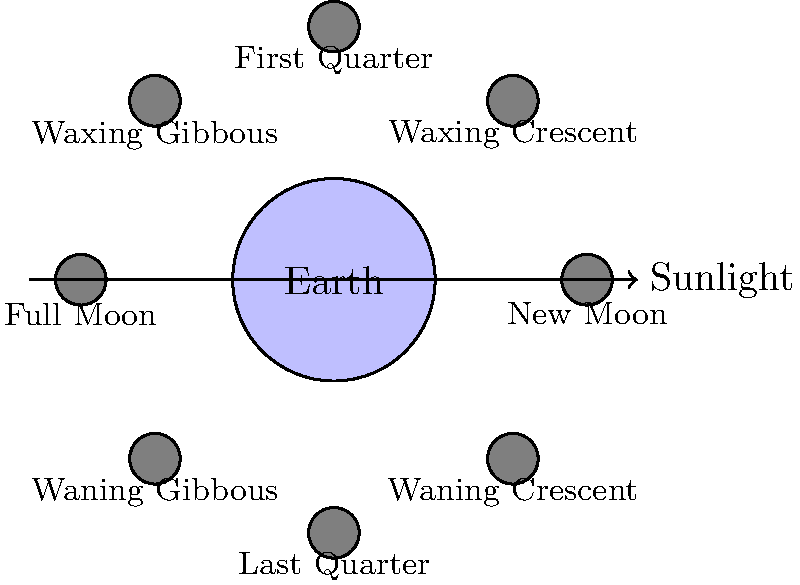As an ambassador representing a country involved in diplomatic relations, you're attending a global conference on space exploration. During a discussion on lunar missions, you're asked about the visibility of different Moon phases from Earth. Based on the diagram, which phase of the Moon would be most visible during a midnight observation from your country's capital? To answer this question, let's break down the Moon's phases and their visibility:

1. The diagram shows the Earth at the center, with the Moon's orbit around it.
2. The arrow on the right indicates the direction of sunlight.
3. The Moon's phases are shown at different positions in its orbit:

   - New Moon: Not visible (dark side facing Earth)
   - Waxing Crescent: Slightly visible in the evening
   - First Quarter: Half visible, sets around midnight
   - Waxing Gibbous: Mostly visible, sets after midnight
   - Full Moon: Fully visible, rises at sunset and sets at sunrise
   - Waning Gibbous: Mostly visible, rises before midnight
   - Last Quarter: Half visible, rises around midnight
   - Waning Crescent: Slightly visible in the morning

4. For a midnight observation, we need a phase that is high in the sky at that time.
5. The Full Moon is the only phase that is consistently visible throughout the night, rising at sunset and setting at sunrise.
6. Therefore, the Full Moon would be the most visible during a midnight observation from any location on Earth, including your country's capital.
Answer: Full Moon 